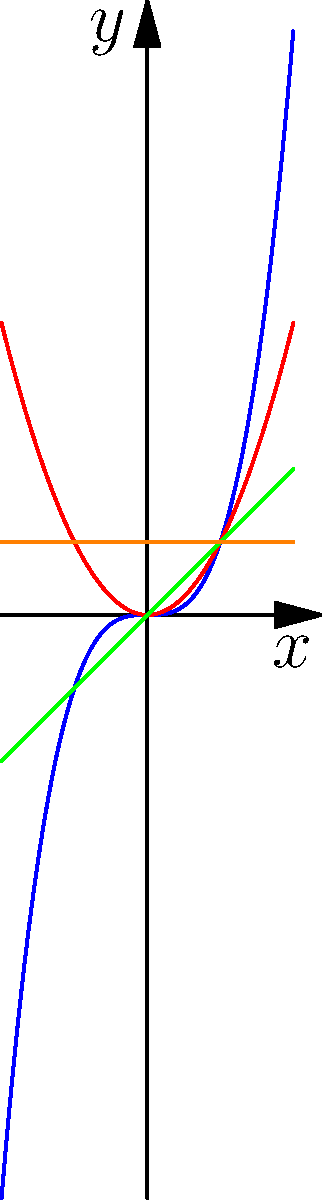As you prepare for your 10-year reunion at Ball State University, you're brushing up on your math skills. Consider the polynomials graphed above: $f_1(x)=x^3$, $f_2(x)=x^2$, $f_3(x)=x$, and $f_4(x)=1$. Which of these functions will approach positive infinity as x approaches both positive and negative infinity? Let's analyze the end behavior of each function as x approaches positive and negative infinity:

1. $f_1(x)=x^3$ (cubic function):
   As $x \to +\infty$, $f_1(x) \to +\infty$
   As $x \to -\infty$, $f_1(x) \to -\infty$

2. $f_2(x)=x^2$ (quadratic function):
   As $x \to +\infty$, $f_2(x) \to +\infty$
   As $x \to -\infty$, $f_2(x) \to +\infty$

3. $f_3(x)=x$ (linear function):
   As $x \to +\infty$, $f_3(x) \to +\infty$
   As $x \to -\infty$, $f_3(x) \to -\infty$

4. $f_4(x)=1$ (constant function):
   As $x \to +\infty$, $f_4(x) = 1$
   As $x \to -\infty$, $f_4(x) = 1$

The only function that approaches positive infinity as x approaches both positive and negative infinity is $f_2(x)=x^2$. This is because it's an even-degree polynomial with a positive leading coefficient, which always results in a U-shaped graph that opens upward.
Answer: $f_2(x)=x^2$ 